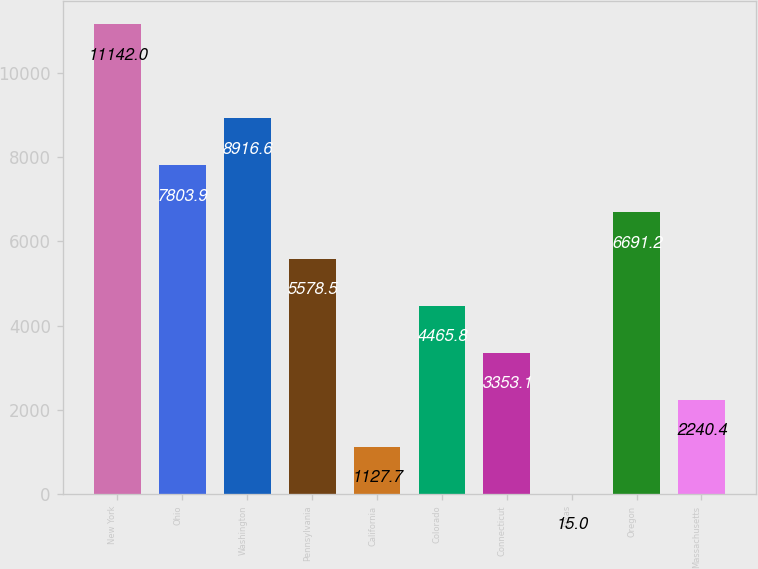Convert chart to OTSL. <chart><loc_0><loc_0><loc_500><loc_500><bar_chart><fcel>New York<fcel>Ohio<fcel>Washington<fcel>Pennsylvania<fcel>California<fcel>Colorado<fcel>Connecticut<fcel>Texas<fcel>Oregon<fcel>Massachusetts<nl><fcel>11142<fcel>7803.9<fcel>8916.6<fcel>5578.5<fcel>1127.7<fcel>4465.8<fcel>3353.1<fcel>15<fcel>6691.2<fcel>2240.4<nl></chart> 